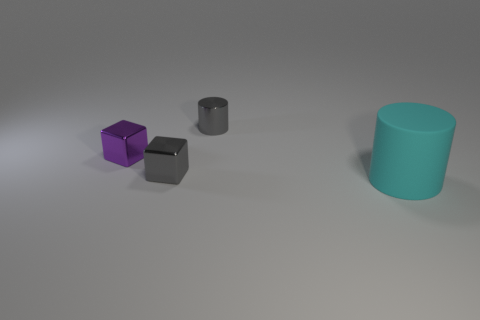Are there any other things that are the same size as the purple metallic block?
Provide a short and direct response. Yes. Is the shiny cylinder the same size as the purple metal block?
Keep it short and to the point. Yes. How many cyan rubber objects are the same size as the gray cylinder?
Offer a very short reply. 0. The metal object that is the same color as the metal cylinder is what shape?
Keep it short and to the point. Cube. Do the gray thing that is in front of the gray metal cylinder and the cylinder that is behind the large cyan rubber cylinder have the same material?
Your response must be concise. Yes. Is there any other thing that has the same shape as the tiny purple thing?
Provide a short and direct response. Yes. What color is the metallic cylinder?
Your response must be concise. Gray. What number of other shiny objects are the same shape as the small purple metallic object?
Offer a terse response. 1. What color is the metallic cylinder that is the same size as the gray block?
Ensure brevity in your answer.  Gray. Are there any purple shiny spheres?
Your answer should be very brief. No. 